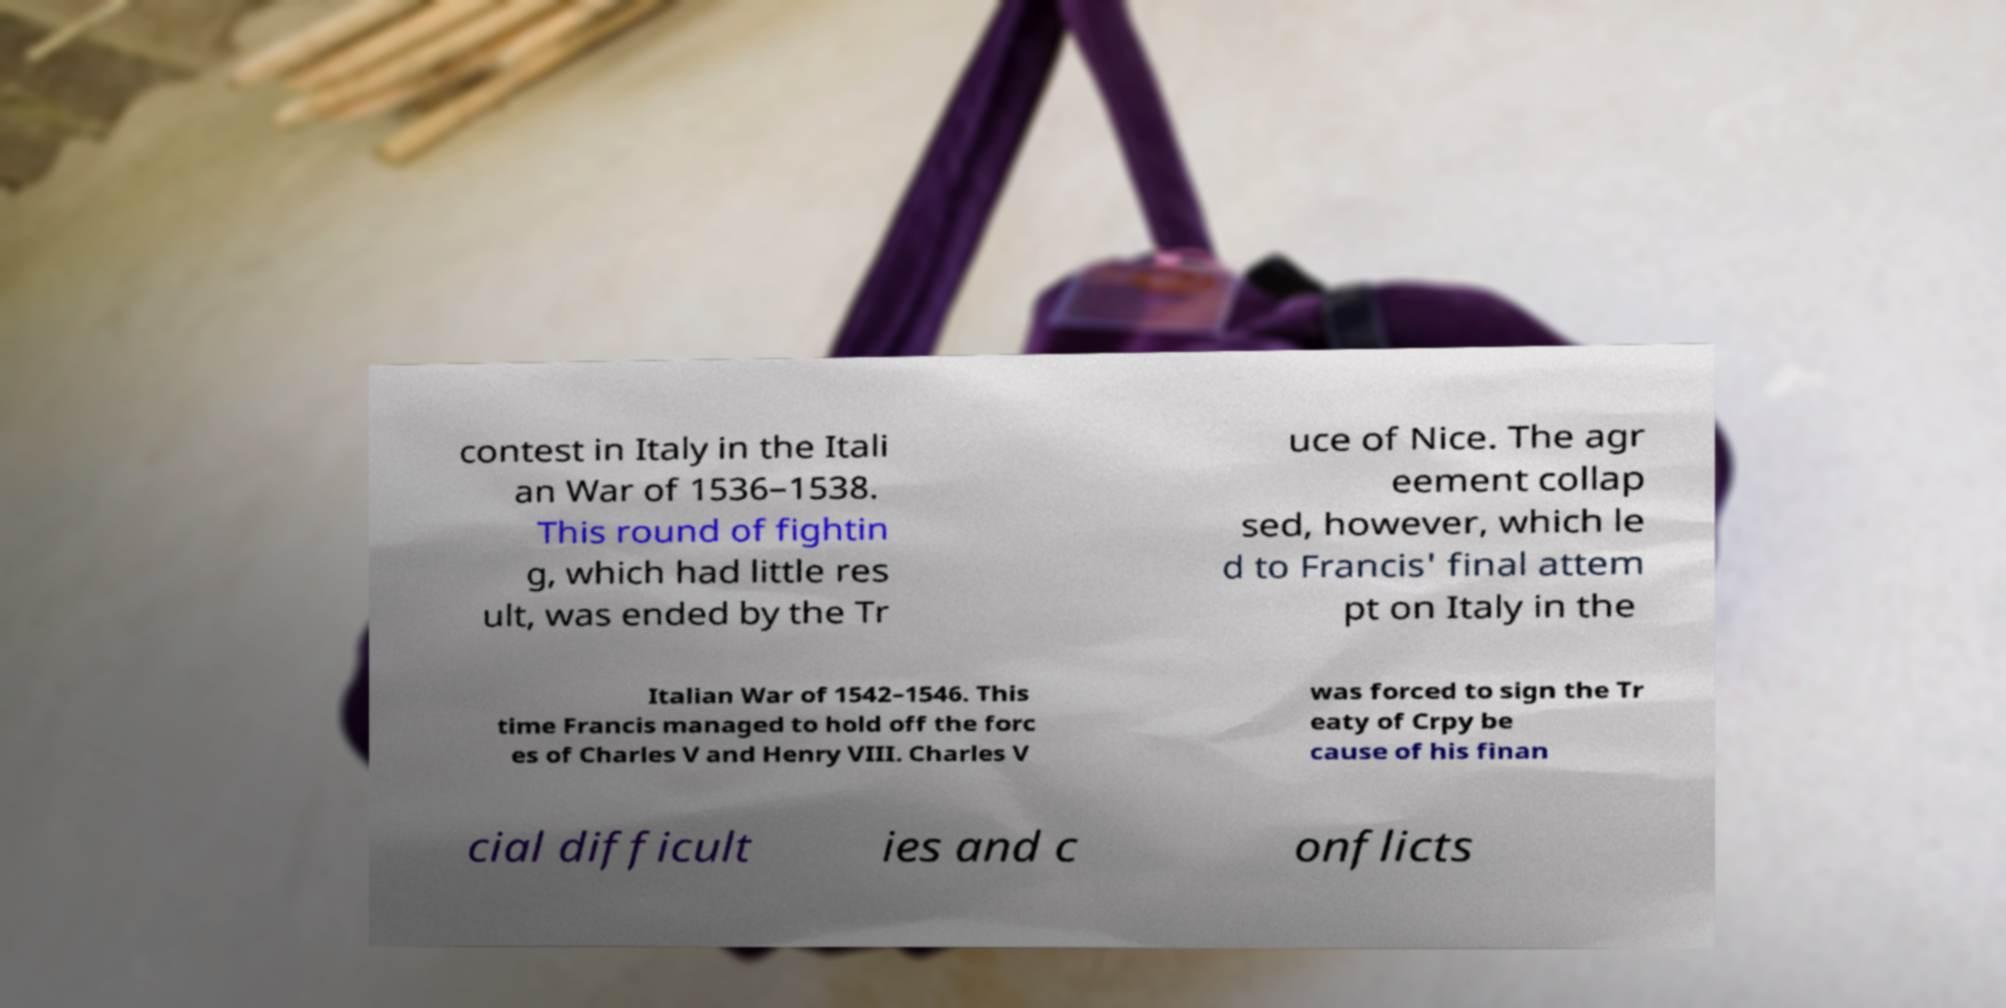Please identify and transcribe the text found in this image. contest in Italy in the Itali an War of 1536–1538. This round of fightin g, which had little res ult, was ended by the Tr uce of Nice. The agr eement collap sed, however, which le d to Francis' final attem pt on Italy in the Italian War of 1542–1546. This time Francis managed to hold off the forc es of Charles V and Henry VIII. Charles V was forced to sign the Tr eaty of Crpy be cause of his finan cial difficult ies and c onflicts 